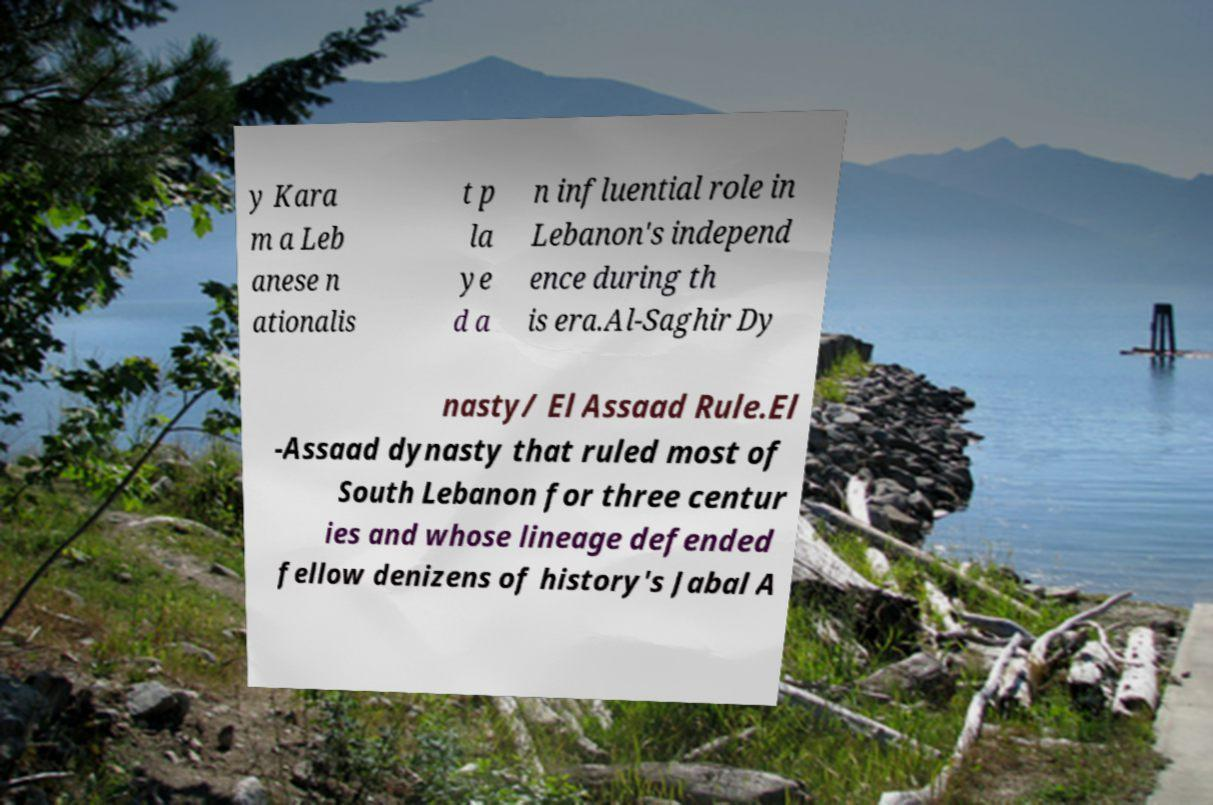Please read and relay the text visible in this image. What does it say? y Kara m a Leb anese n ationalis t p la ye d a n influential role in Lebanon's independ ence during th is era.Al-Saghir Dy nasty/ El Assaad Rule.El -Assaad dynasty that ruled most of South Lebanon for three centur ies and whose lineage defended fellow denizens of history's Jabal A 